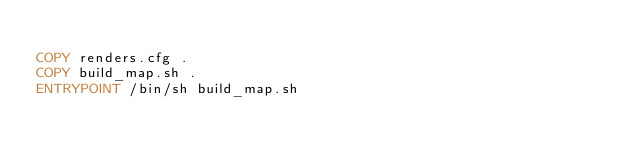Convert code to text. <code><loc_0><loc_0><loc_500><loc_500><_Dockerfile_>
COPY renders.cfg .
COPY build_map.sh .
ENTRYPOINT /bin/sh build_map.sh
</code> 